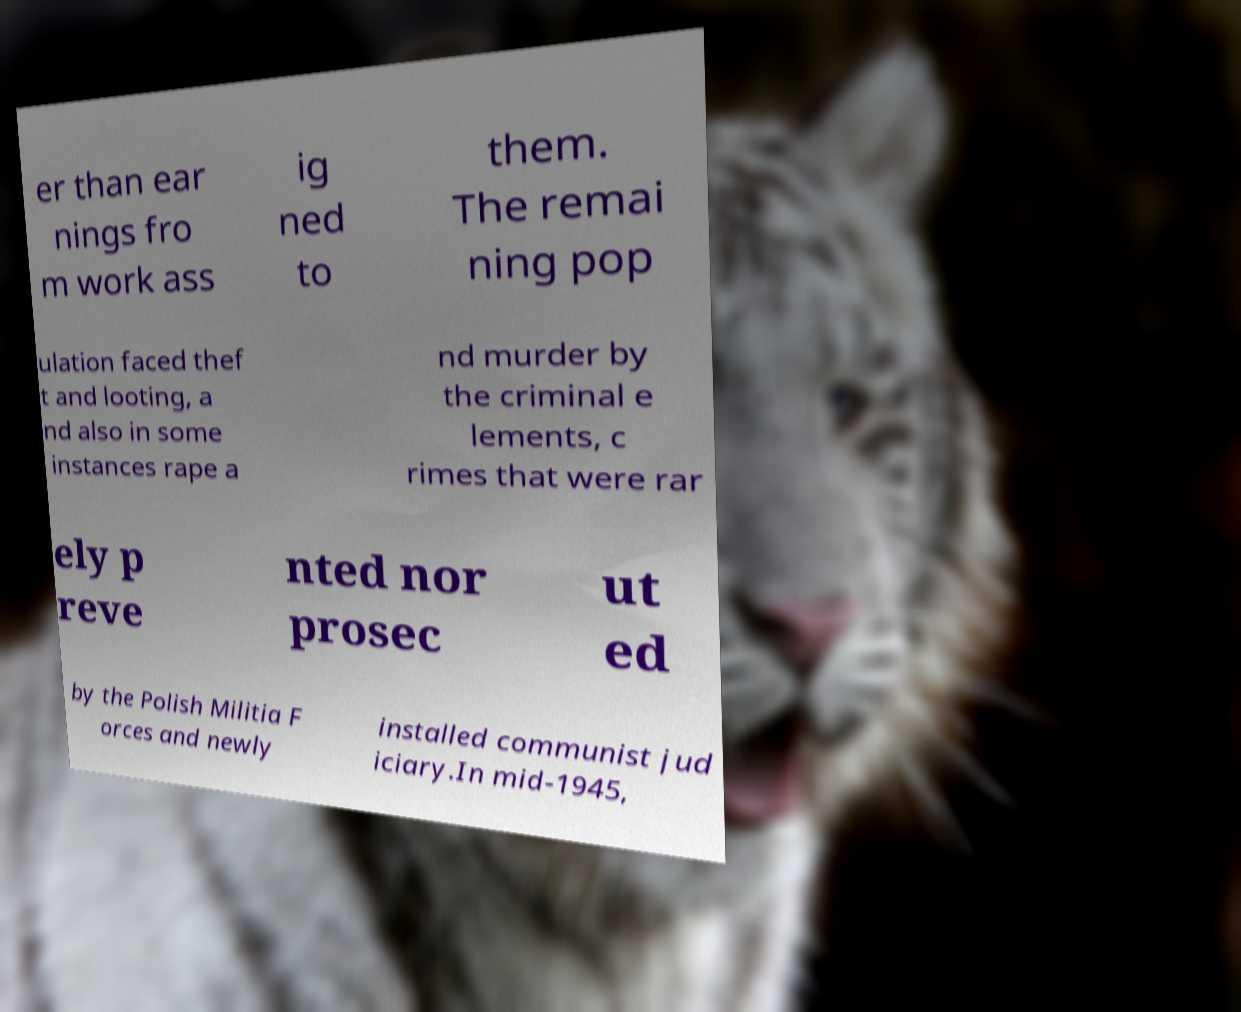There's text embedded in this image that I need extracted. Can you transcribe it verbatim? er than ear nings fro m work ass ig ned to them. The remai ning pop ulation faced thef t and looting, a nd also in some instances rape a nd murder by the criminal e lements, c rimes that were rar ely p reve nted nor prosec ut ed by the Polish Militia F orces and newly installed communist jud iciary.In mid-1945, 